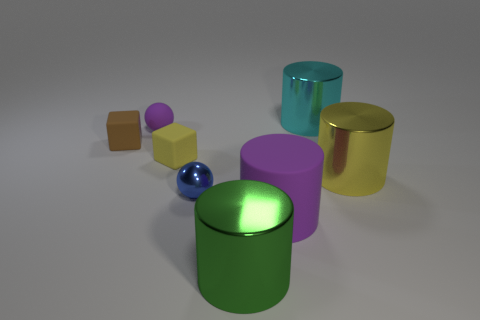Subtract all shiny cylinders. How many cylinders are left? 1 Add 1 large green rubber cylinders. How many objects exist? 9 Subtract 3 cylinders. How many cylinders are left? 1 Subtract all green spheres. How many green blocks are left? 0 Subtract all big cyan metallic objects. Subtract all small brown things. How many objects are left? 6 Add 4 green metal cylinders. How many green metal cylinders are left? 5 Add 1 green things. How many green things exist? 2 Subtract all yellow cylinders. How many cylinders are left? 3 Subtract 1 purple balls. How many objects are left? 7 Subtract all spheres. How many objects are left? 6 